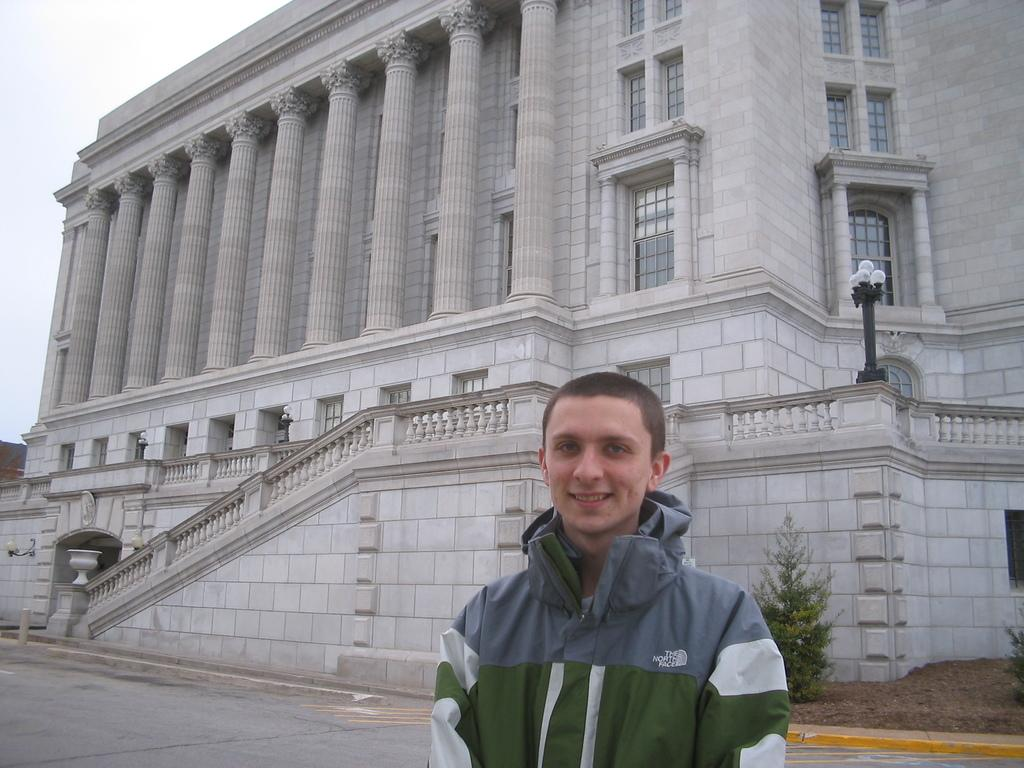Provide a one-sentence caption for the provided image. A boy wearing a north face jacket stands in front of a building with large pillars. 